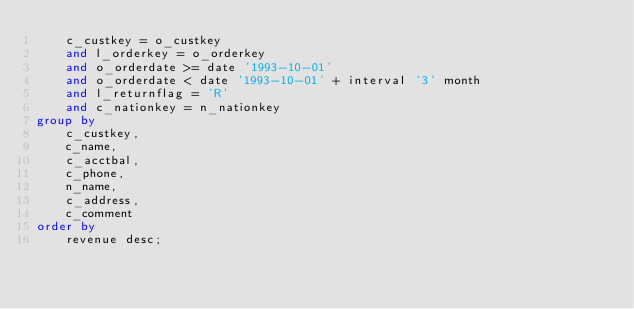Convert code to text. <code><loc_0><loc_0><loc_500><loc_500><_SQL_>	c_custkey = o_custkey
	and l_orderkey = o_orderkey
	and o_orderdate >= date '1993-10-01'
	and o_orderdate < date '1993-10-01' + interval '3' month
	and l_returnflag = 'R'
	and c_nationkey = n_nationkey
group by
	c_custkey,
	c_name,
	c_acctbal,
	c_phone,
	n_name,
	c_address,
	c_comment
order by
	revenue desc;
</code> 